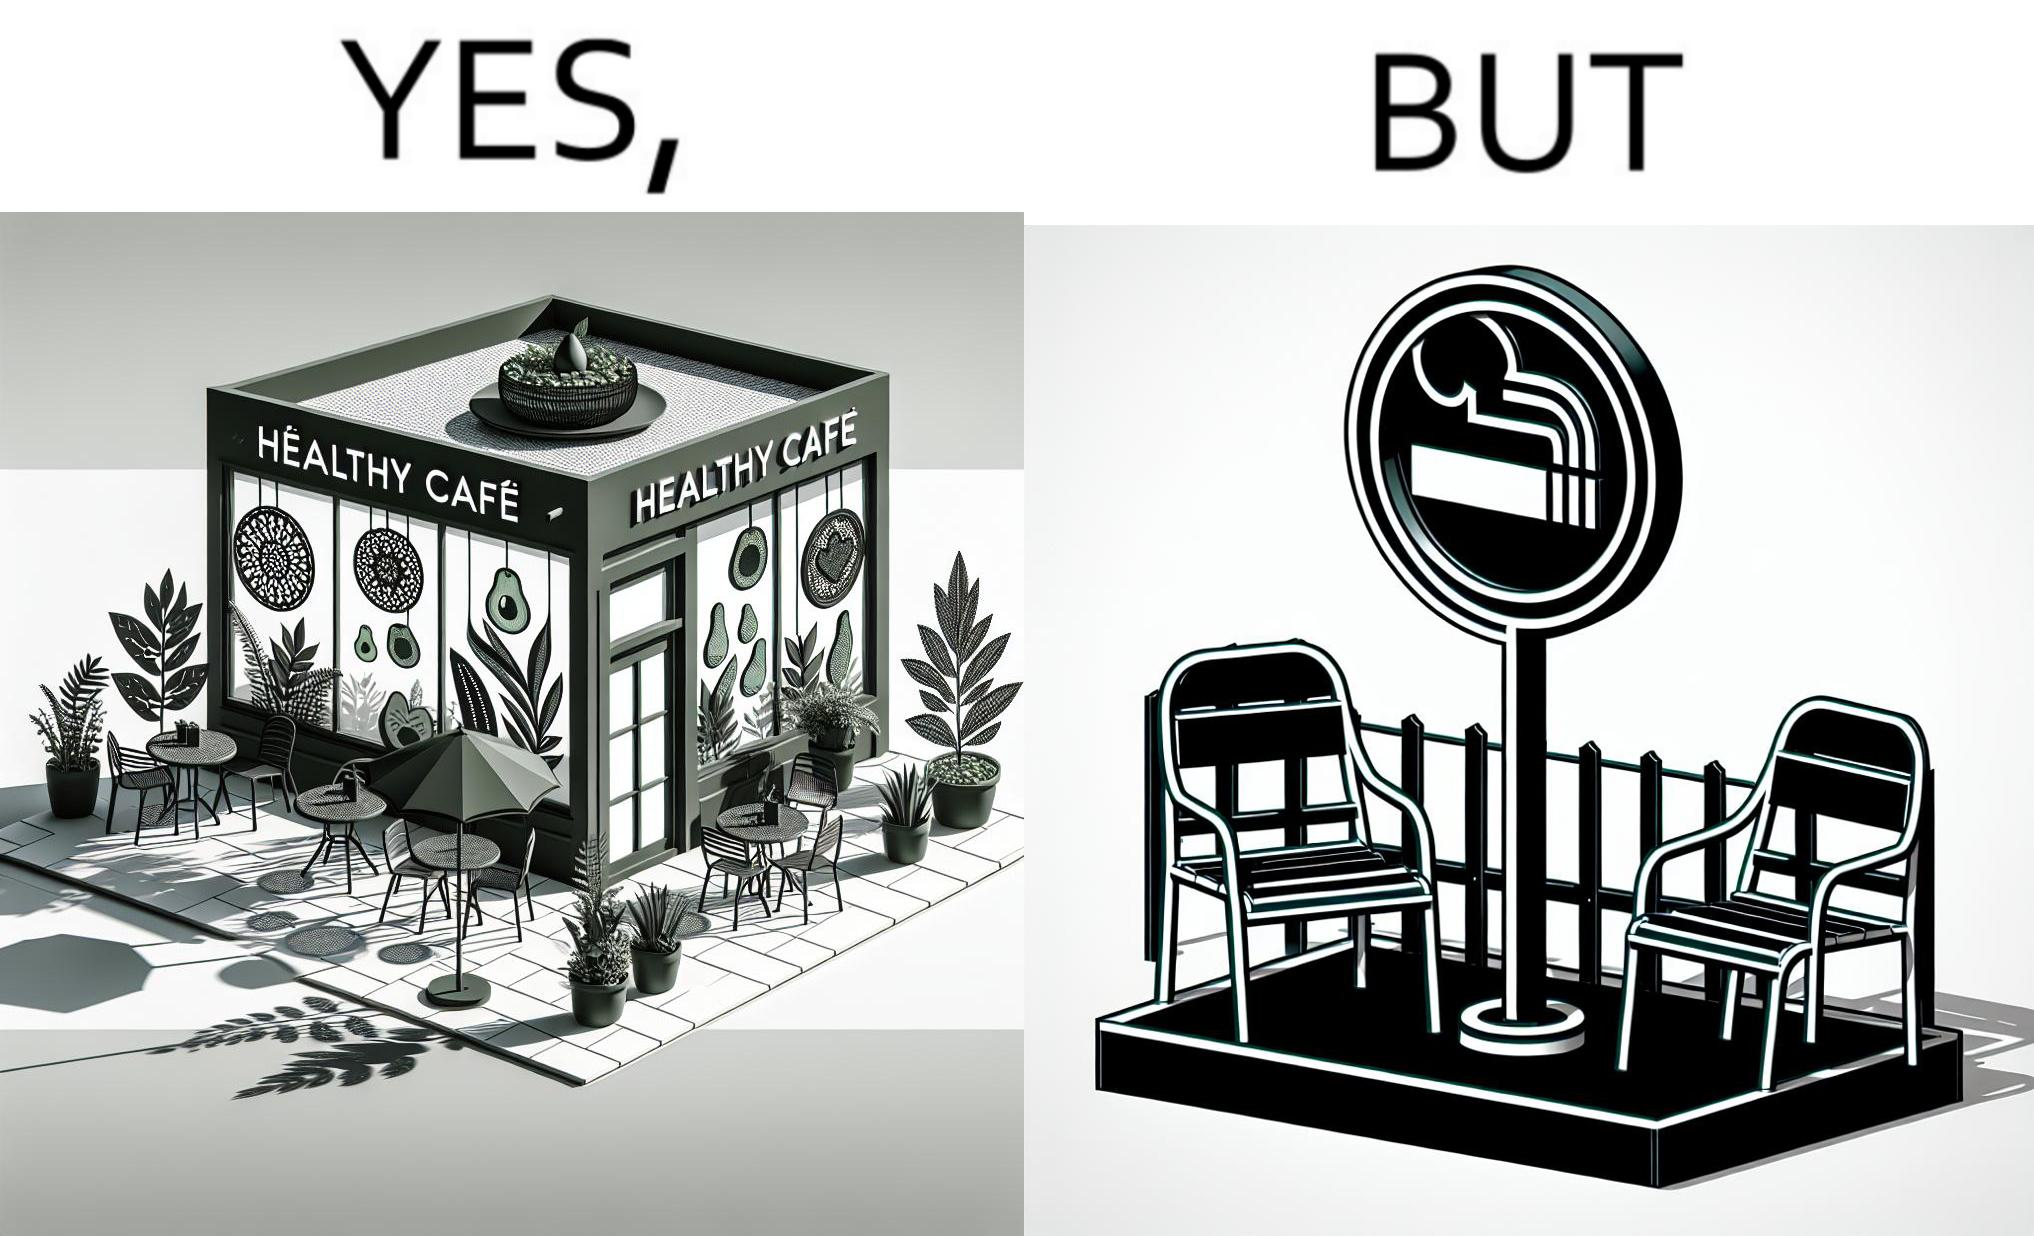What does this image depict? This image is funny because an eatery that calls itself the "healthy" cafe also has a smoking area, which is not very "healthy". If it really was a healthy cafe, it would not have a smoking area as smoking is injurious to health. Satire on the behavior of humans - both those that operate this cafe who made the decision of allowing smoking and creating a designated smoking area, and those that visit this healthy cafe to become "healthy", but then also indulge in very unhealthy habits simultaneously. 